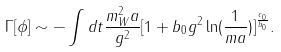Convert formula to latex. <formula><loc_0><loc_0><loc_500><loc_500>\Gamma [ \phi ] \sim - \int d t \frac { m _ { W } ^ { 2 } a } { g ^ { 2 } } [ 1 + b _ { 0 } g ^ { 2 } \ln ( \frac { 1 } { m a } ) ] ^ { \frac { c _ { 0 } } { b _ { 0 } } } .</formula> 